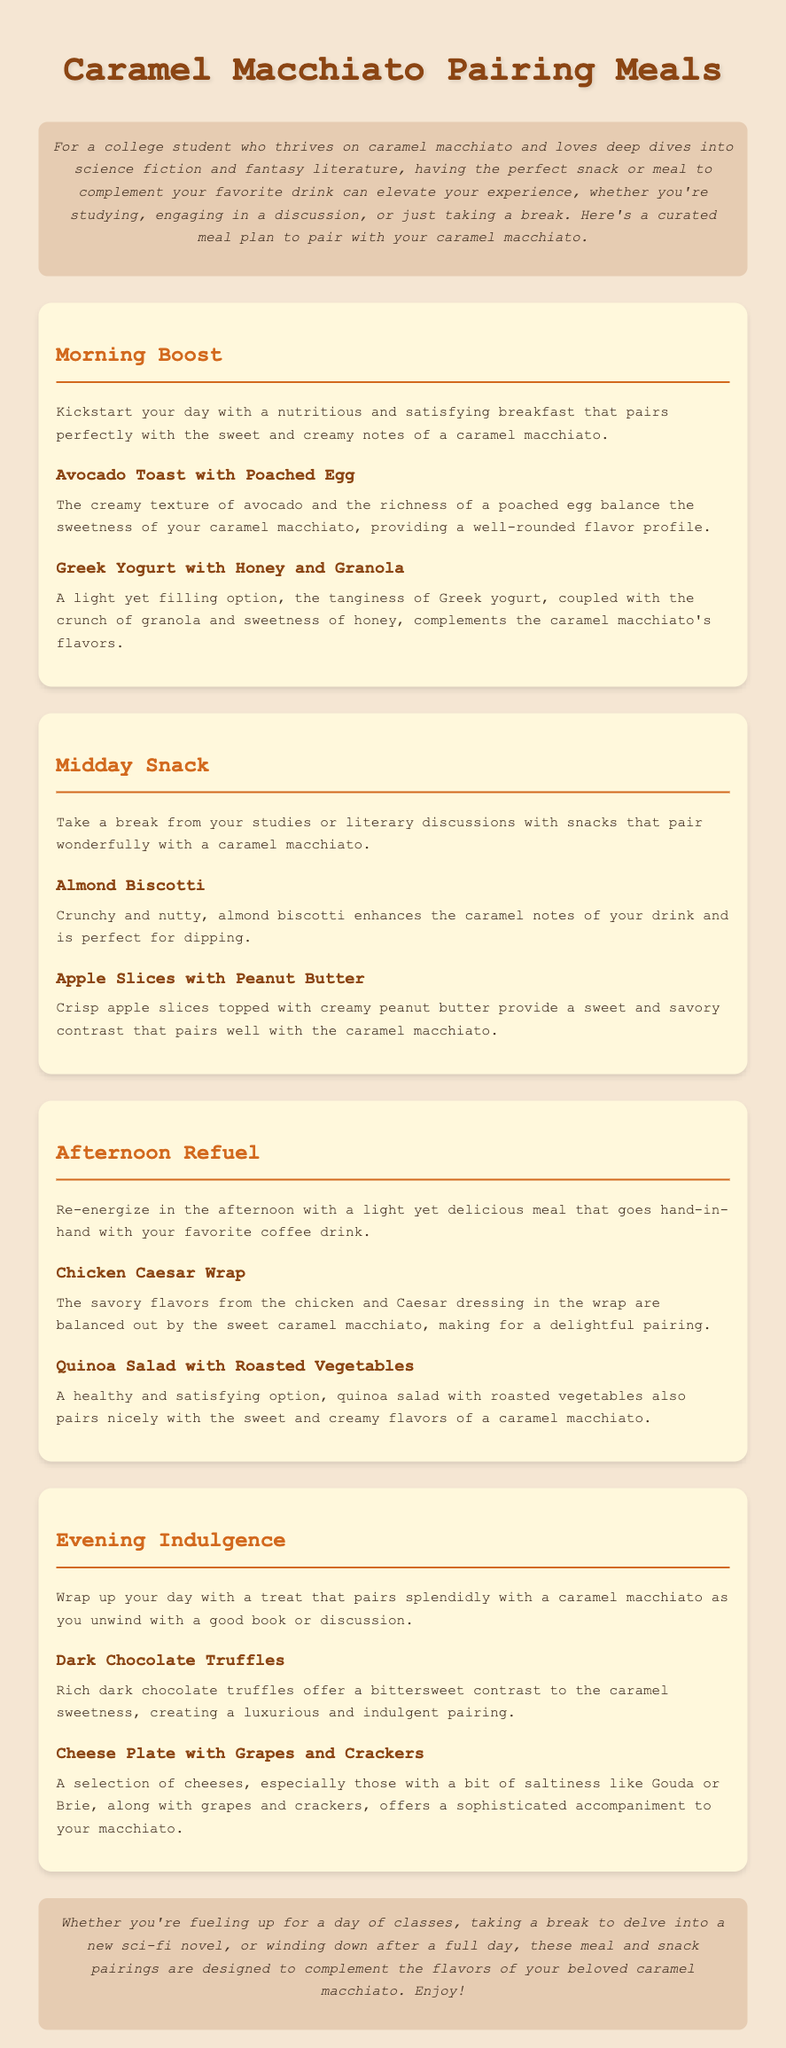What is the title of the document? The title of the document is found in the header section as "Caramel Macchiato Pairing Meals."
Answer: Caramel Macchiato Pairing Meals What meal is suggested for a midday snack? The document lists "Almond Biscotti" as a suggested midday snack.
Answer: Almond Biscotti What is one of the ingredients in the "Quinoa Salad with Roasted Vegetables"? "Quinoa Salad with Roasted Vegetables" is a meal that includes quinoa, which is a primary ingredient.
Answer: Quinoa How many sections are in the document? The document has four main sections: Morning Boost, Midday Snack, Afternoon Refuel, and Evening Indulgence.
Answer: Four What flavor profile does the "Apple Slices with Peanut Butter" provide? The combination of "Crisp apple slices topped with creamy peanut butter" offers a clear description of sweet and savory flavors.
Answer: Sweet and savory Which snack pairs well with a caramel macchiato for evening indulgence? The document mentions "Dark Chocolate Truffles" as a pairing for evening indulgence.
Answer: Dark Chocolate Truffles What type of cheese is mentioned in the cheese plate suggestion? The cheese plate includes Gouda, which is one of the cheeses listed.
Answer: Gouda What does the introduction encourage readers to do? The introduction suggests that having a perfect snack or meal can elevate the experience while enjoying a caramel macchiato.
Answer: Elevate your experience 